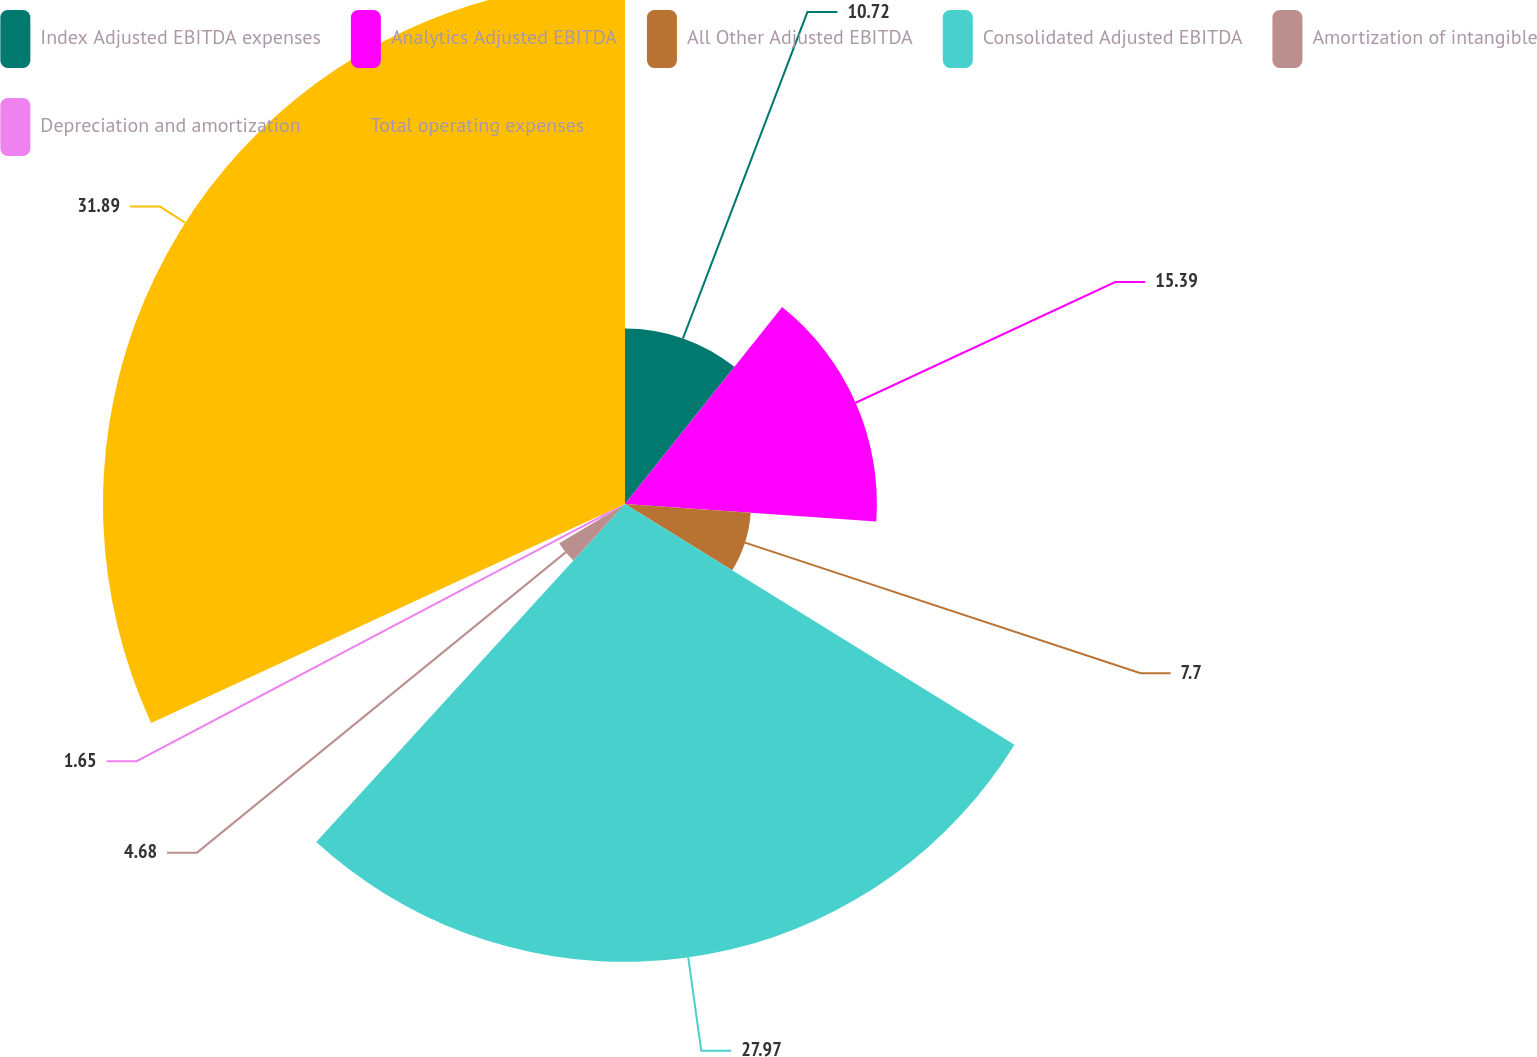<chart> <loc_0><loc_0><loc_500><loc_500><pie_chart><fcel>Index Adjusted EBITDA expenses<fcel>Analytics Adjusted EBITDA<fcel>All Other Adjusted EBITDA<fcel>Consolidated Adjusted EBITDA<fcel>Amortization of intangible<fcel>Depreciation and amortization<fcel>Total operating expenses<nl><fcel>10.72%<fcel>15.39%<fcel>7.7%<fcel>27.97%<fcel>4.68%<fcel>1.65%<fcel>31.89%<nl></chart> 